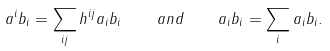Convert formula to latex. <formula><loc_0><loc_0><loc_500><loc_500>a ^ { i } b _ { i } = \sum _ { i j } h ^ { i j } a _ { i } b _ { i } \quad a n d \quad a _ { i } b _ { i } = \sum _ { i } a _ { i } b _ { i } .</formula> 